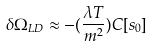<formula> <loc_0><loc_0><loc_500><loc_500>\delta \Omega _ { L D } \approx - ( \frac { \lambda T } { m ^ { 2 } } ) C [ s _ { 0 } ]</formula> 